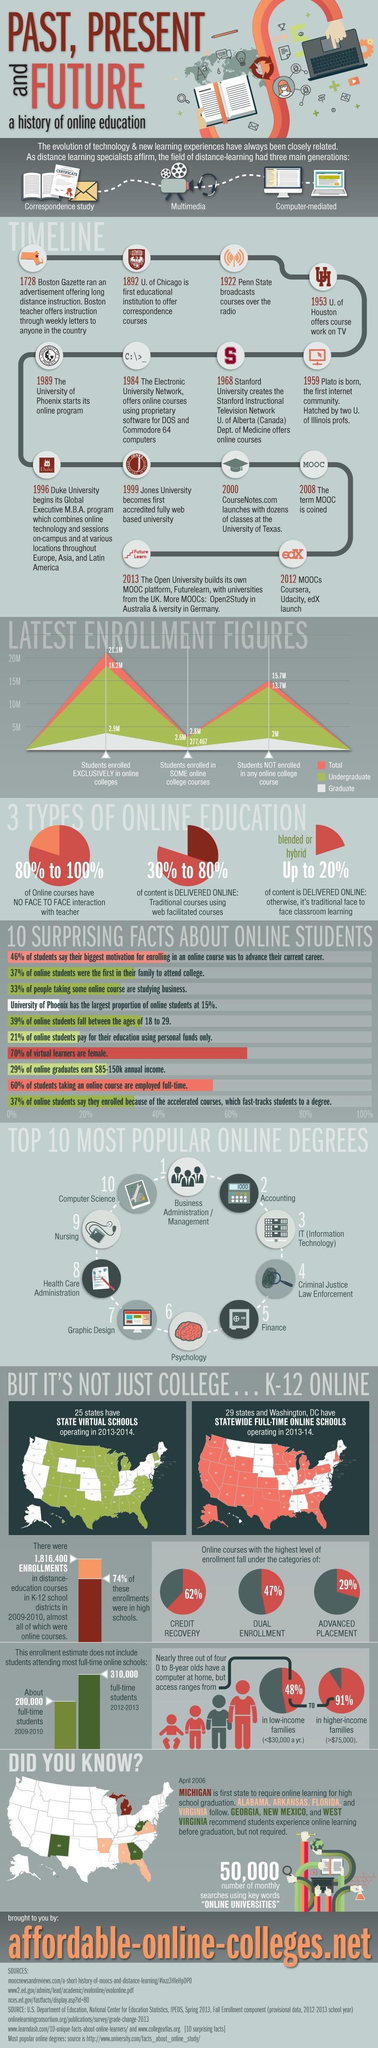Which color is used to represent graduate-red, orange, white, or green?
Answer the question with a short phrase. white Which is the second state to require online learning for high school graduation? Alabama What is the difference between full-time students in 2009-2010 and 2012-2013? 110000 